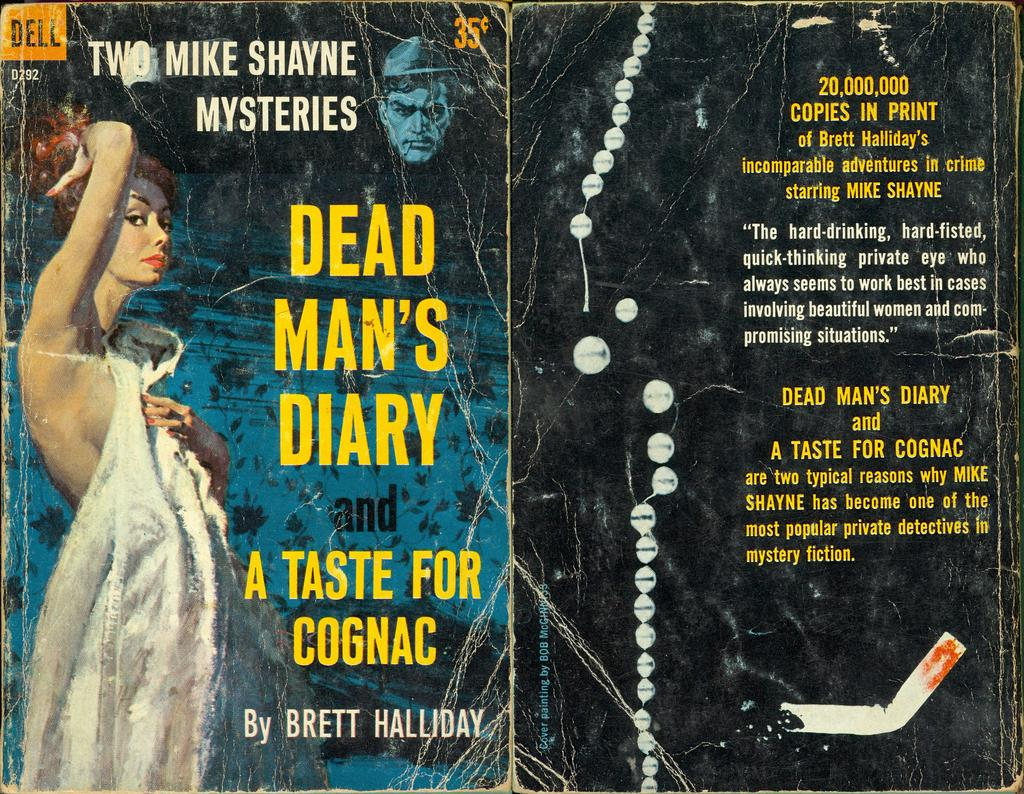<image>
Write a terse but informative summary of the picture. A book that is titled "Dead Man's Diary and a Taste for Cognac" 